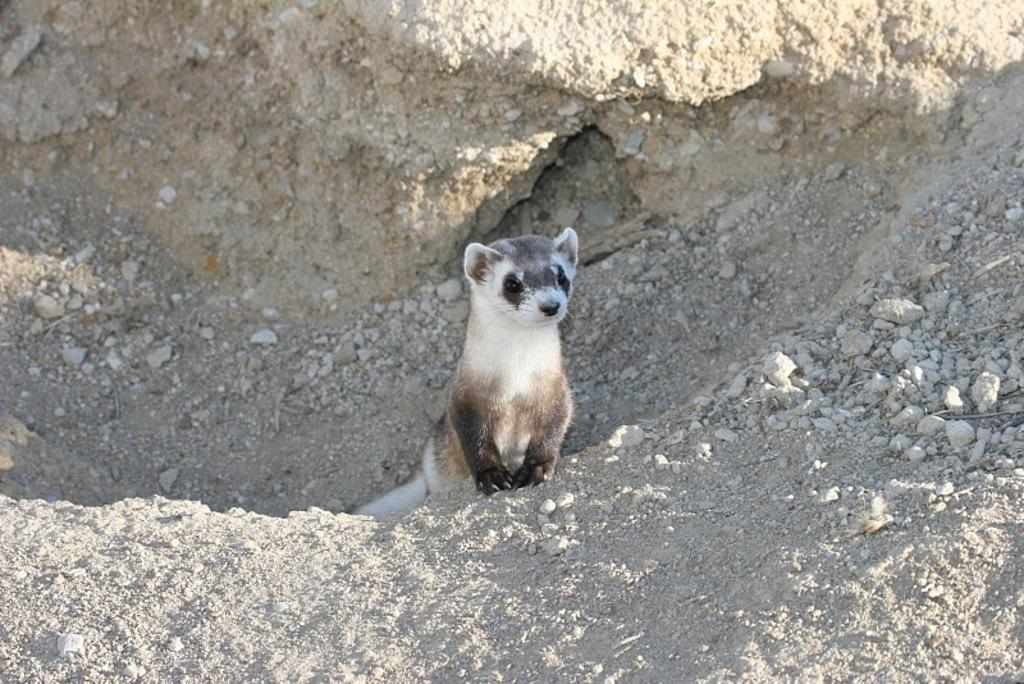What type of living creature is present in the image? There is an animal in the image. What can be seen on the ground in the image? There are stones on the ground in the image. Is the animal in the image being held in a prison? There is no indication of a prison or any confinement in the image; it simply shows an animal and stones on the ground. 